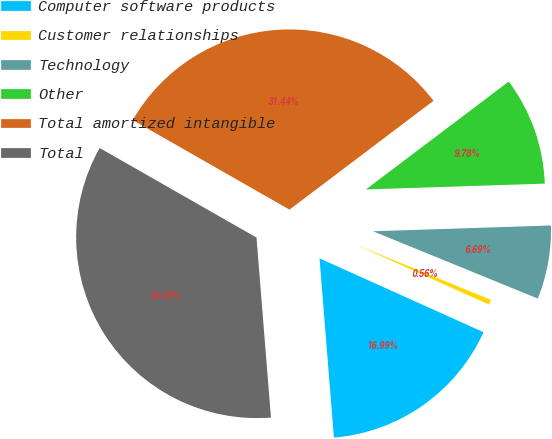<chart> <loc_0><loc_0><loc_500><loc_500><pie_chart><fcel>Computer software products<fcel>Customer relationships<fcel>Technology<fcel>Other<fcel>Total amortized intangible<fcel>Total<nl><fcel>16.99%<fcel>0.56%<fcel>6.69%<fcel>9.78%<fcel>31.44%<fcel>34.53%<nl></chart> 